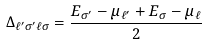Convert formula to latex. <formula><loc_0><loc_0><loc_500><loc_500>\Delta _ { \ell ^ { \prime } \sigma ^ { \prime } \ell \sigma } = \frac { E _ { \sigma ^ { \prime } } - \mu _ { \ell ^ { \prime } } + E _ { \sigma } - \mu _ { \ell } } { 2 }</formula> 